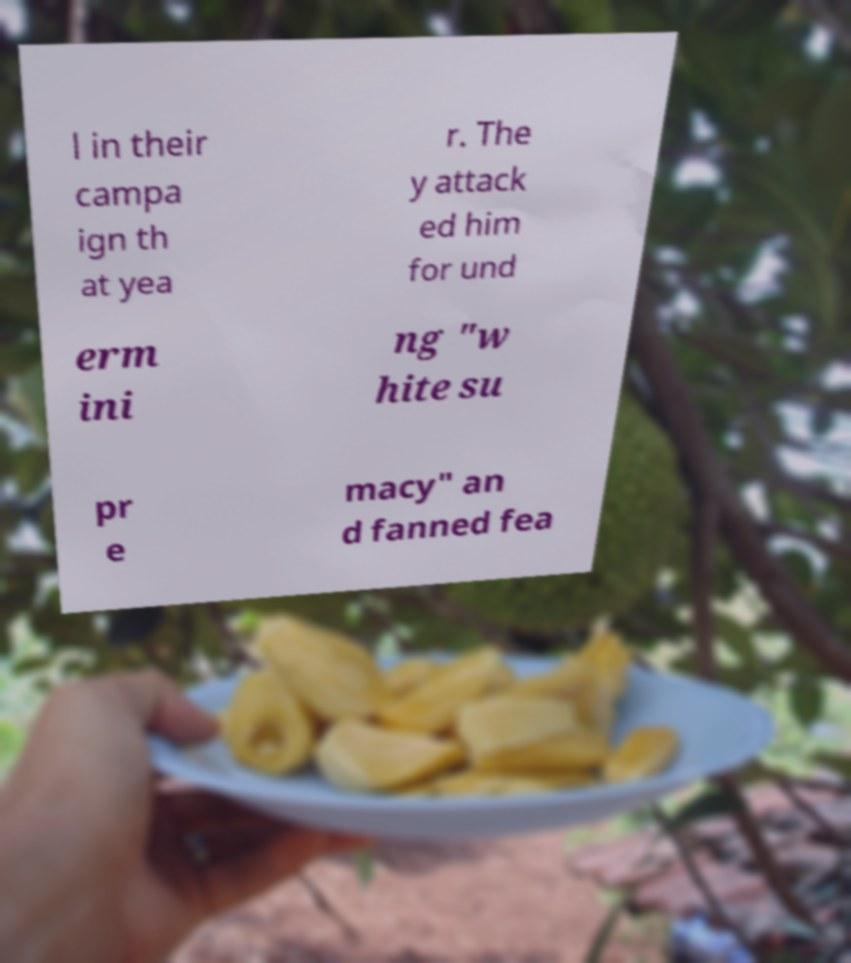There's text embedded in this image that I need extracted. Can you transcribe it verbatim? l in their campa ign th at yea r. The y attack ed him for und erm ini ng "w hite su pr e macy" an d fanned fea 